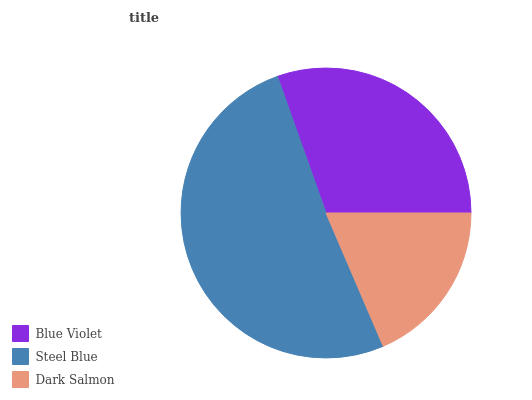Is Dark Salmon the minimum?
Answer yes or no. Yes. Is Steel Blue the maximum?
Answer yes or no. Yes. Is Steel Blue the minimum?
Answer yes or no. No. Is Dark Salmon the maximum?
Answer yes or no. No. Is Steel Blue greater than Dark Salmon?
Answer yes or no. Yes. Is Dark Salmon less than Steel Blue?
Answer yes or no. Yes. Is Dark Salmon greater than Steel Blue?
Answer yes or no. No. Is Steel Blue less than Dark Salmon?
Answer yes or no. No. Is Blue Violet the high median?
Answer yes or no. Yes. Is Blue Violet the low median?
Answer yes or no. Yes. Is Dark Salmon the high median?
Answer yes or no. No. Is Steel Blue the low median?
Answer yes or no. No. 